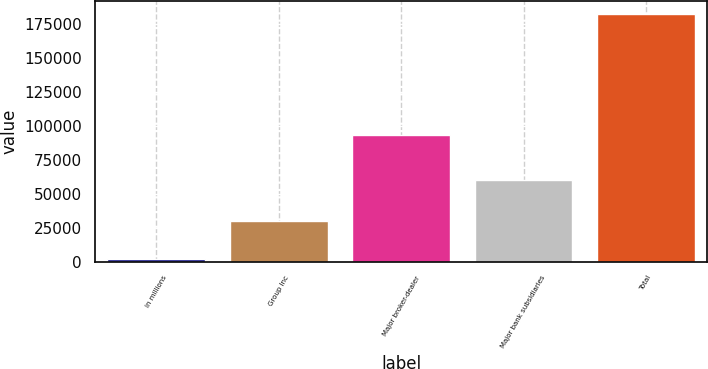<chart> <loc_0><loc_0><loc_500><loc_500><bar_chart><fcel>in millions<fcel>Group Inc<fcel>Major broker-dealer<fcel>Major bank subsidiaries<fcel>Total<nl><fcel>2013<fcel>29752<fcel>93103<fcel>59795<fcel>182650<nl></chart> 